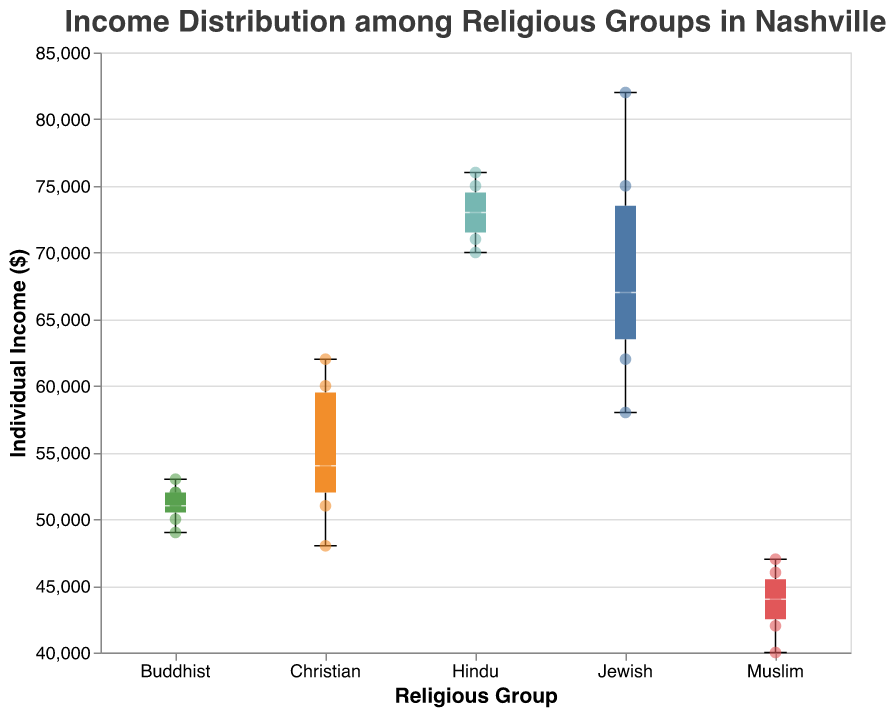What's the title of the plot? The title of the plot is displayed at the top of the figure and it generally summarizes the main topic or data being visualized.
Answer: "Income Distribution among Religious Groups in Nashville" How many religious groups are represented in the box plot? By looking at the x-axis, which categorizes by religious groups, you can count the number of distinct labels.
Answer: 5 Which religious group has the highest median income? The median income is represented by the central line within each box. By comparing these lines across the groups, the one with the highest central line has the highest median income.
Answer: Jewish Which religious group has the widest range of individual incomes? The range is indicated by the whiskers of the box plot. The group with the longest distance between the minimum and maximum whiskers has the widest range.
Answer: Jewish What is the median income of Buddhists? The median income is represented by a line within the box plot for the Buddhist group. By observing this line, you can determine the median income for this group.
Answer: 51000 Which group has the smallest income range and what is that range? The income range is the difference between the highest and lowest whiskers of the box plots. Identify the group with the shortest distance between these two points and calculate the difference.
Answer: Christian, 14000 Compare the highest incomes among the religious groups. Which group has the highest individual income and what is that value? The highest individual income is identified by the uppermost whisker of the box plots for each group. The longest whisker points to the group with the highest income.
Answer: Jewish, 82000 How does the median income of Hindus compare to that of Jews? The median income for Hindus and Jews is represented by the central lines within their respective box plots. Compare the heights of these lines to see which is higher.
Answer: Lower for Hindus How many data points are there for the Christian group? Each of the individually plotted scatter points represents a data point. Count these points for the Christian group.
Answer: 7 What can you infer about the distribution of incomes for Muslims compared to Jews? Muslims have a lower income range and median compared to Jews, suggesting a more compact and lower income distribution for Muslims. This can be inferred from the shorter whiskers and lower median line of the Muslim box plot compared to that of the Jews.
Answer: Muslims have lower and less varied incomes compared to Jews 